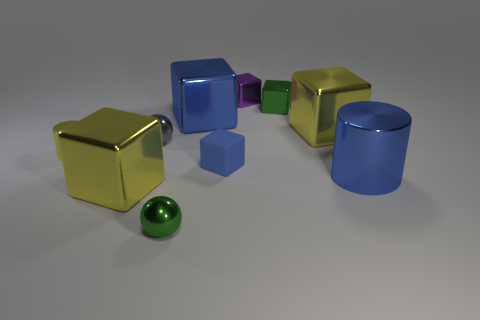Subtract all cylinders. How many objects are left? 8 Subtract 2 spheres. How many spheres are left? 0 Subtract all brown cylinders. Subtract all purple blocks. How many cylinders are left? 2 Subtract all yellow balls. How many green cubes are left? 1 Subtract all small blue cubes. Subtract all tiny cubes. How many objects are left? 6 Add 6 tiny rubber things. How many tiny rubber things are left? 7 Add 7 yellow cubes. How many yellow cubes exist? 9 Subtract all blue cubes. How many cubes are left? 4 Subtract all blue blocks. How many blocks are left? 4 Subtract 0 brown blocks. How many objects are left? 10 